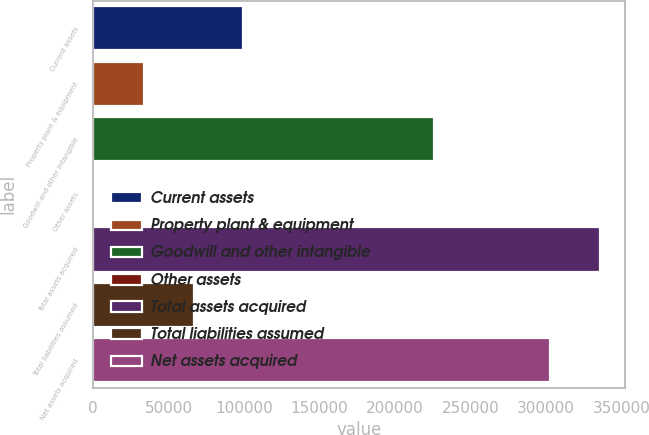Convert chart to OTSL. <chart><loc_0><loc_0><loc_500><loc_500><bar_chart><fcel>Current assets<fcel>Property plant & equipment<fcel>Goodwill and other intangible<fcel>Other assets<fcel>Total assets acquired<fcel>Total liabilities assumed<fcel>Net assets acquired<nl><fcel>99589.7<fcel>33635.9<fcel>225682<fcel>659<fcel>335592<fcel>66612.8<fcel>302615<nl></chart> 